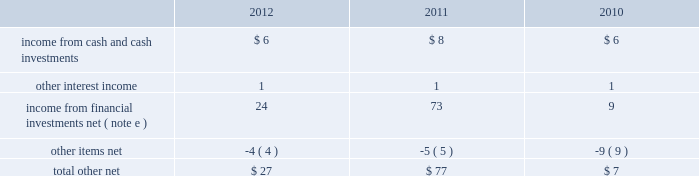Masco corporation notes to consolidated financial statements ( continued ) o .
Segment information ( continued ) ( 1 ) included in net sales were export sales from the u.s .
Of $ 229 million , $ 241 million and $ 246 million in 2012 , 2011 and 2010 , respectively .
( 2 ) excluded from net sales were intra-company sales between segments of approximately two percent of net sales in each of 2012 , 2011 and 2010 .
( 3 ) included in net sales were sales to one customer of $ 2143 million , $ 1984 million and $ 1993 million in 2012 , 2011 and 2010 , respectively .
Such net sales were included in the following segments : cabinets and related products , plumbing products , decorative architectural products and other specialty products .
( 4 ) net sales from the company 2019s operations in the u.s .
Were $ 5793 million , $ 5394 million and $ 5618 million in 2012 , 2011 and 2010 , respectively .
( 5 ) net sales , operating ( loss ) profit , property additions and depreciation and amortization expense for 2012 , 2011 and 2010 excluded the results of businesses reported as discontinued operations in 2012 , 2011 and 2010 .
( 6 ) included in segment operating profit ( loss ) for 2012 was an impairment charge for other intangible assets as follows : other specialty products 2013 $ 42 million .
Included in segment operating ( loss ) profit for 2011 were impairment charges for goodwill and other intangible assets as follows : cabinets and related products 2013 $ 44 million ; plumbing products 2013 $ 1 million ; decorative architectural products 2013 $ 75 million ; and other specialty products 2013 $ 374 million .
Included in segment operating ( loss ) profit for 2010 were impairment charges for goodwill and other intangible assets as follows : plumbing products 2013 $ 1 million ; and installation and other services 2013 $ 697 million .
( 7 ) general corporate expense , net included those expenses not specifically attributable to the company 2019s segments .
( 8 ) the charge for litigation settlement , net in 2012 primarily relates to a business in the installation and other services segment and in 2011 relates to business units in the cabinets and related products and the other specialty products segments .
( 9 ) long-lived assets of the company 2019s operations in the u.s .
And europe were $ 2795 million and $ 567 million , $ 2964 million and $ 565 million , and $ 3684 million and $ 617 million at december 31 , 2012 , 2011 and 2010 , respectively .
( 10 ) segment assets for 2012 and 2011 excluded the assets of businesses reported as discontinued operations in the respective years .
Severance costs as part of the company 2019s continuing review of its operations , actions were taken during 2012 , 2011 and 2010 to respond to market conditions .
The company recorded charges related to severance and early retirement programs of $ 36 million , $ 17 million and $ 14 million for the years ended december 31 , 2012 , 2011 and 2010 , respectively .
Such charges are principally reflected in the statement of operations in selling , general and administrative expenses and were paid when incurred .
Other income ( expense ) , net other , net , which is included in other income ( expense ) , net , was as follows , in millions: .
Other items , net , included realized foreign currency transaction losses of $ 2 million , $ 5 million and $ 2 million in 2012 , 2011 and 2010 , respectively , as well as other miscellaneous items. .
What was the percent of the change in income from cash and cash investments from 2010 to 2011? 
Rationale: the income from cash and cash investments increased by 33.3% from 2010 to 2011
Computations: ((8 - 6) / 6)
Answer: 0.33333. Masco corporation notes to consolidated financial statements ( continued ) o .
Segment information ( continued ) ( 1 ) included in net sales were export sales from the u.s .
Of $ 229 million , $ 241 million and $ 246 million in 2012 , 2011 and 2010 , respectively .
( 2 ) excluded from net sales were intra-company sales between segments of approximately two percent of net sales in each of 2012 , 2011 and 2010 .
( 3 ) included in net sales were sales to one customer of $ 2143 million , $ 1984 million and $ 1993 million in 2012 , 2011 and 2010 , respectively .
Such net sales were included in the following segments : cabinets and related products , plumbing products , decorative architectural products and other specialty products .
( 4 ) net sales from the company 2019s operations in the u.s .
Were $ 5793 million , $ 5394 million and $ 5618 million in 2012 , 2011 and 2010 , respectively .
( 5 ) net sales , operating ( loss ) profit , property additions and depreciation and amortization expense for 2012 , 2011 and 2010 excluded the results of businesses reported as discontinued operations in 2012 , 2011 and 2010 .
( 6 ) included in segment operating profit ( loss ) for 2012 was an impairment charge for other intangible assets as follows : other specialty products 2013 $ 42 million .
Included in segment operating ( loss ) profit for 2011 were impairment charges for goodwill and other intangible assets as follows : cabinets and related products 2013 $ 44 million ; plumbing products 2013 $ 1 million ; decorative architectural products 2013 $ 75 million ; and other specialty products 2013 $ 374 million .
Included in segment operating ( loss ) profit for 2010 were impairment charges for goodwill and other intangible assets as follows : plumbing products 2013 $ 1 million ; and installation and other services 2013 $ 697 million .
( 7 ) general corporate expense , net included those expenses not specifically attributable to the company 2019s segments .
( 8 ) the charge for litigation settlement , net in 2012 primarily relates to a business in the installation and other services segment and in 2011 relates to business units in the cabinets and related products and the other specialty products segments .
( 9 ) long-lived assets of the company 2019s operations in the u.s .
And europe were $ 2795 million and $ 567 million , $ 2964 million and $ 565 million , and $ 3684 million and $ 617 million at december 31 , 2012 , 2011 and 2010 , respectively .
( 10 ) segment assets for 2012 and 2011 excluded the assets of businesses reported as discontinued operations in the respective years .
Severance costs as part of the company 2019s continuing review of its operations , actions were taken during 2012 , 2011 and 2010 to respond to market conditions .
The company recorded charges related to severance and early retirement programs of $ 36 million , $ 17 million and $ 14 million for the years ended december 31 , 2012 , 2011 and 2010 , respectively .
Such charges are principally reflected in the statement of operations in selling , general and administrative expenses and were paid when incurred .
Other income ( expense ) , net other , net , which is included in other income ( expense ) , net , was as follows , in millions: .
Other items , net , included realized foreign currency transaction losses of $ 2 million , $ 5 million and $ 2 million in 2012 , 2011 and 2010 , respectively , as well as other miscellaneous items. .
What was the difference in income from financial investments net in millions from 2010 to 2011? 
Computations: (73 - 9)
Answer: 64.0. 